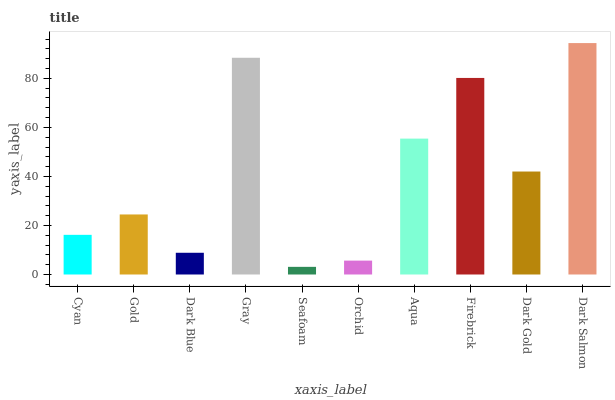Is Seafoam the minimum?
Answer yes or no. Yes. Is Dark Salmon the maximum?
Answer yes or no. Yes. Is Gold the minimum?
Answer yes or no. No. Is Gold the maximum?
Answer yes or no. No. Is Gold greater than Cyan?
Answer yes or no. Yes. Is Cyan less than Gold?
Answer yes or no. Yes. Is Cyan greater than Gold?
Answer yes or no. No. Is Gold less than Cyan?
Answer yes or no. No. Is Dark Gold the high median?
Answer yes or no. Yes. Is Gold the low median?
Answer yes or no. Yes. Is Gray the high median?
Answer yes or no. No. Is Dark Gold the low median?
Answer yes or no. No. 